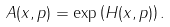<formula> <loc_0><loc_0><loc_500><loc_500>A ( x , p ) = \exp \left ( H ( x , p ) \right ) .</formula> 